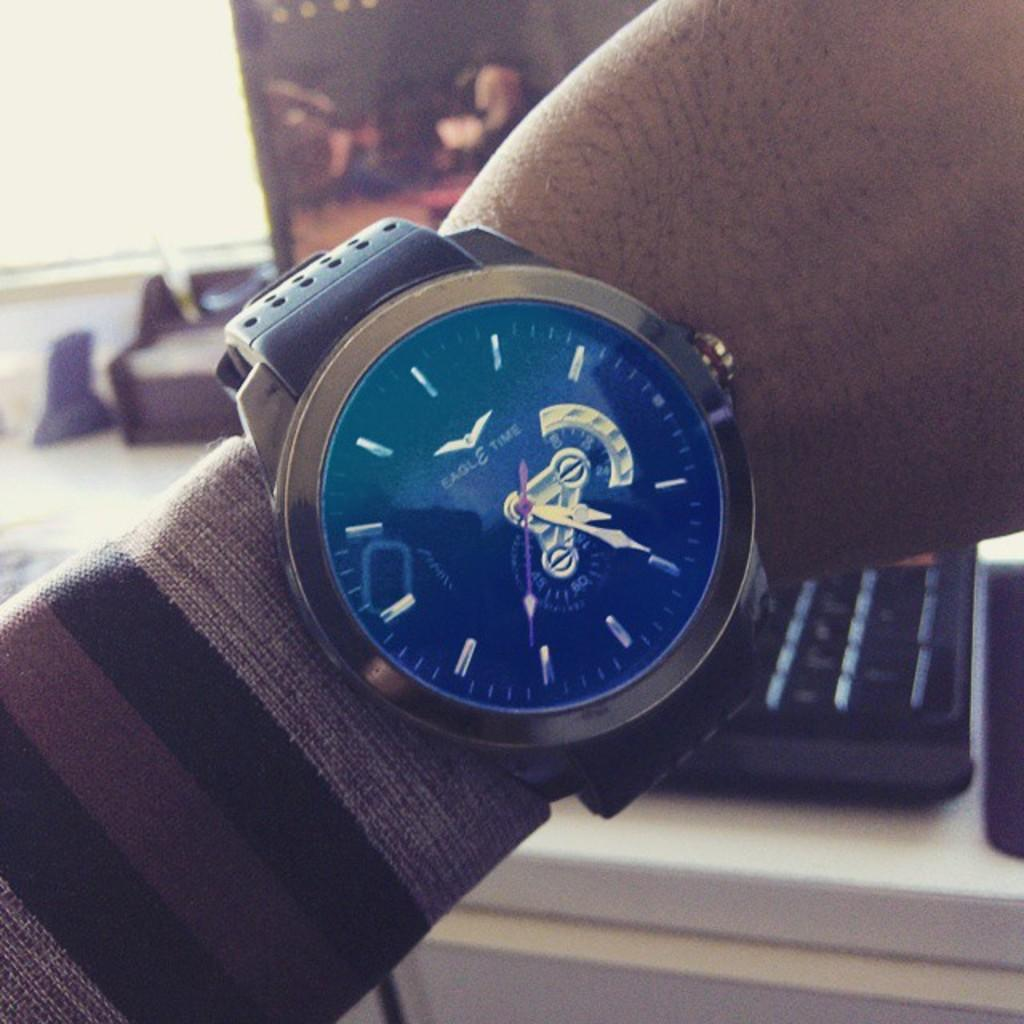<image>
Present a compact description of the photo's key features. A silver and black Eagle Time watch on a man's wrist. 